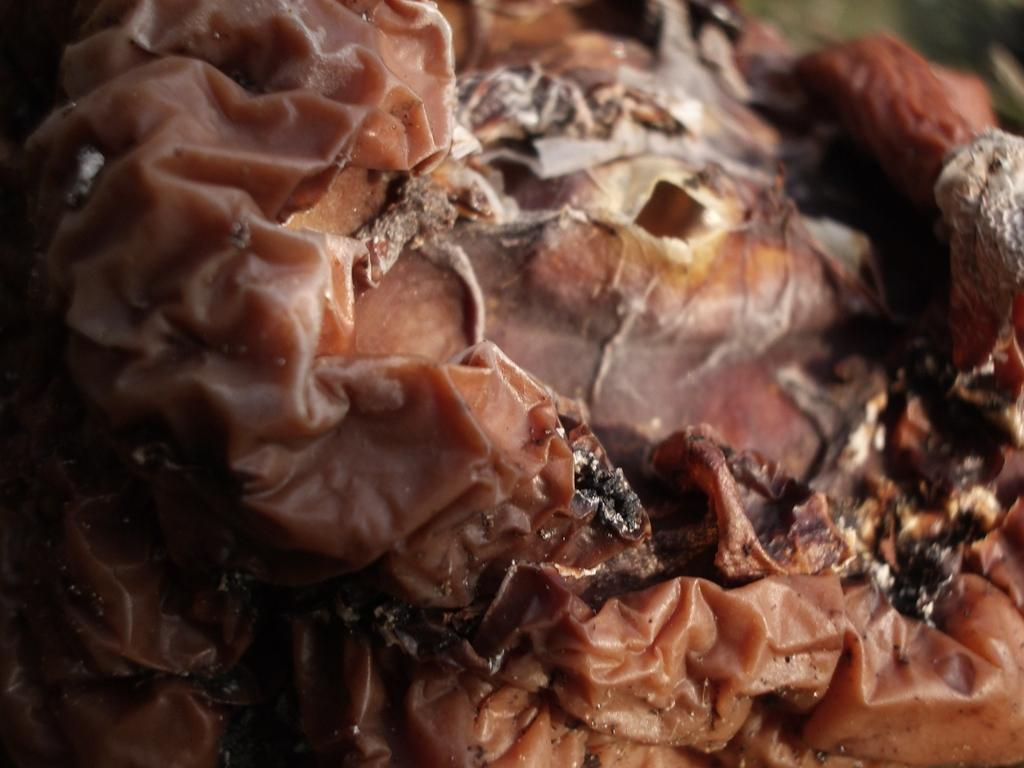What type of dessert is visible in the image? There is a chocolate cake in the image. What type of fowl can be seen eating the chocolate cake in the image? There is no fowl present in the image, and the chocolate cake is not being eaten by any animal. 